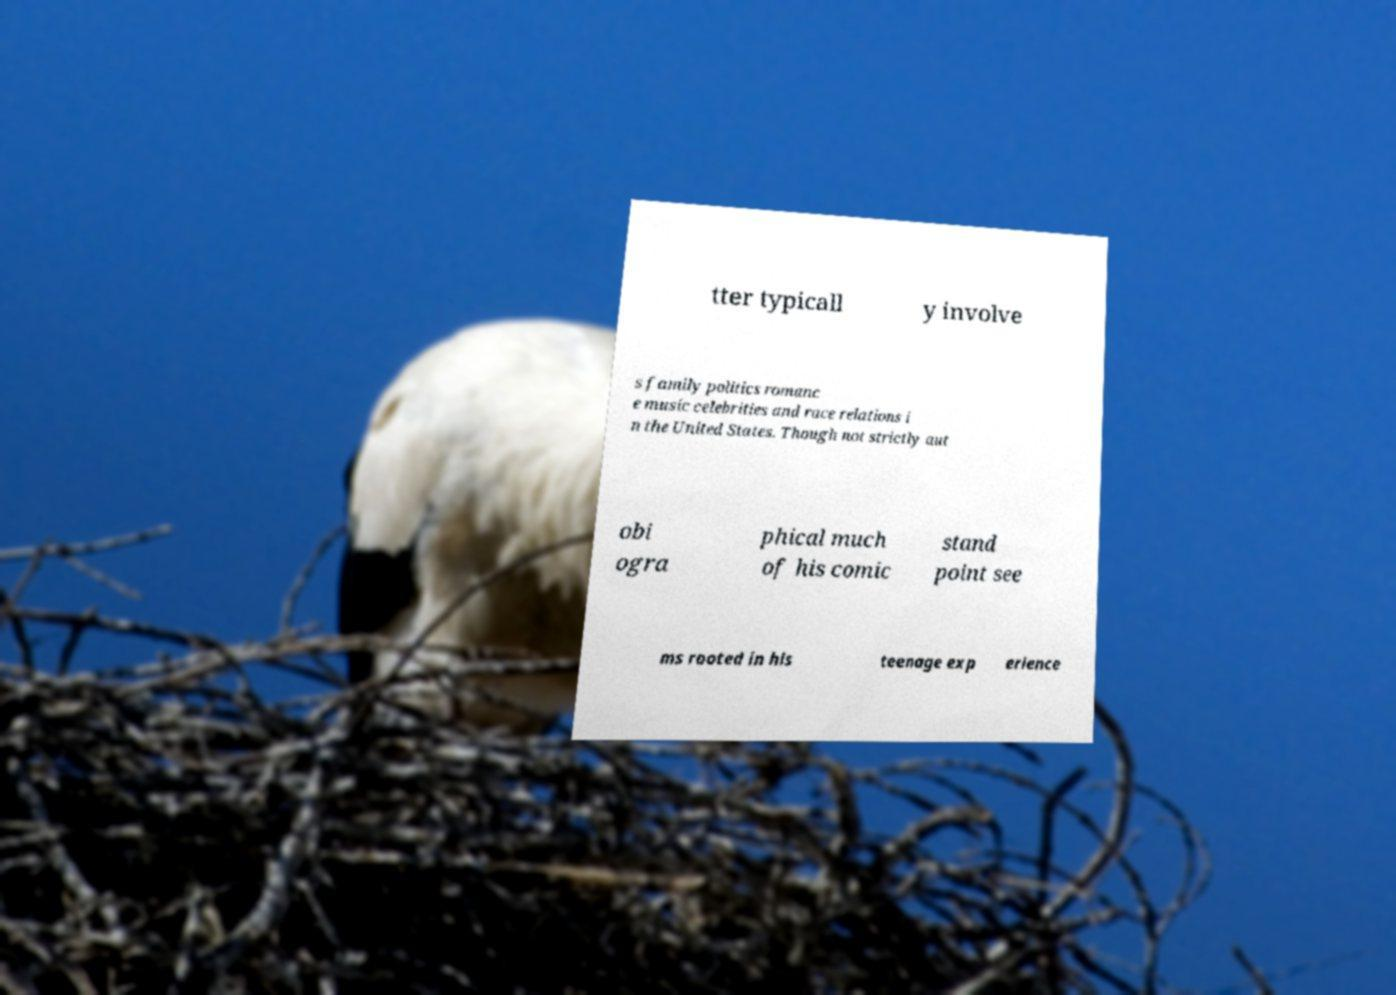What messages or text are displayed in this image? I need them in a readable, typed format. tter typicall y involve s family politics romanc e music celebrities and race relations i n the United States. Though not strictly aut obi ogra phical much of his comic stand point see ms rooted in his teenage exp erience 